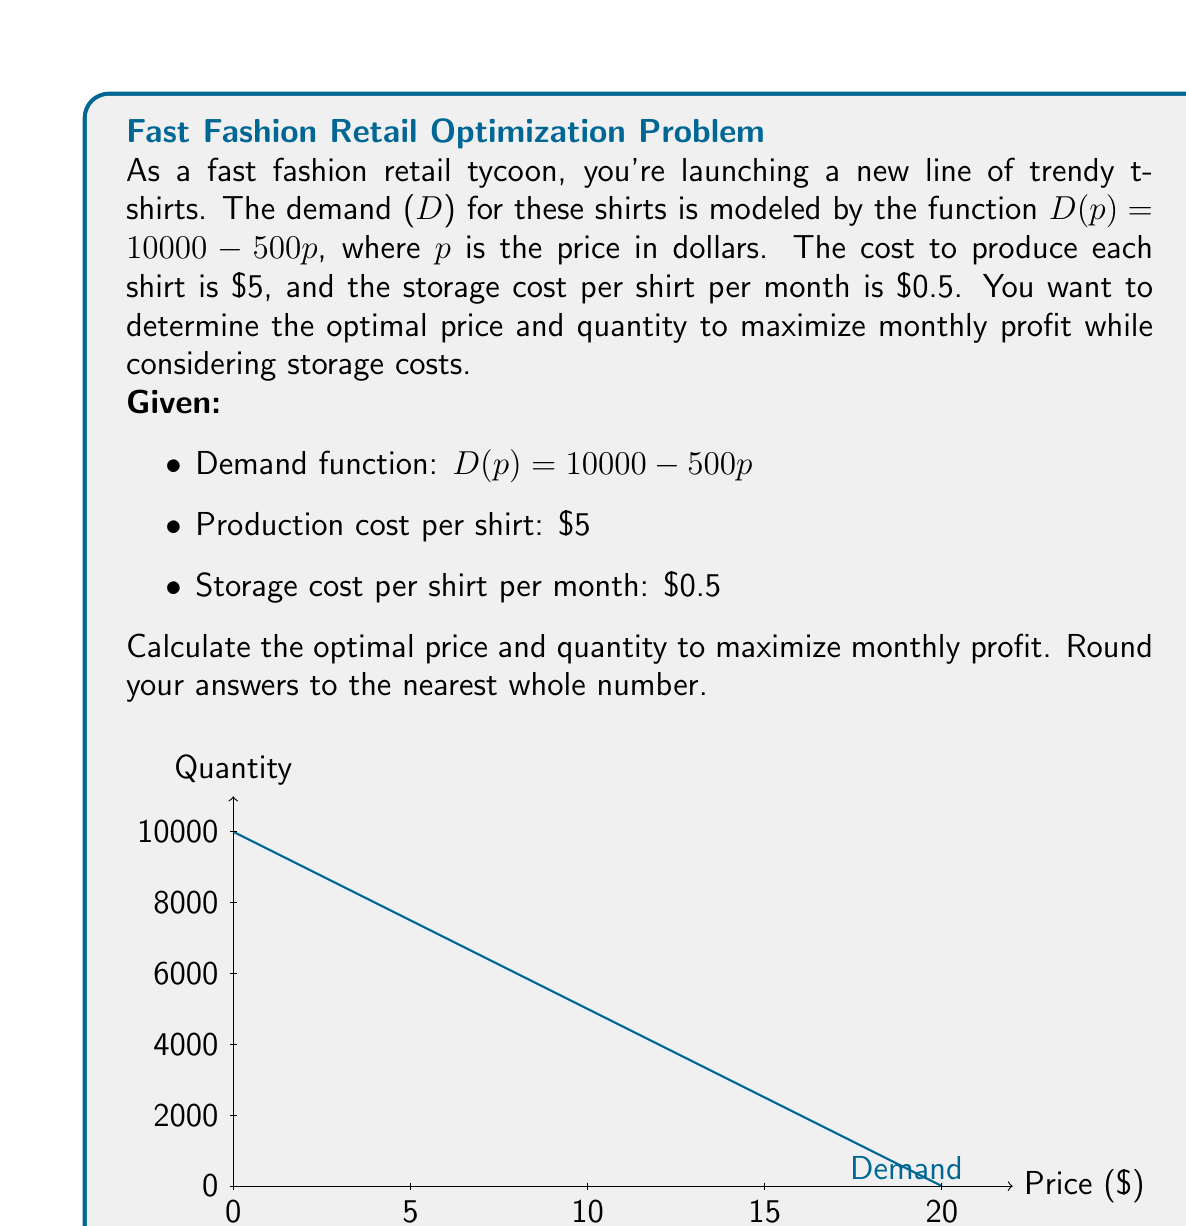Help me with this question. Let's approach this step-by-step:

1) First, we need to express the revenue and cost functions:
   Revenue (R) = p * D(p) = p * (10000 - 500p) = 10000p - 500p²
   Cost (C) = 5D(p) + 0.5D(p) = 5.5D(p) = 5.5(10000 - 500p) = 55000 - 2750p

2) The profit function (P) is revenue minus cost:
   P(p) = R - C = (10000p - 500p²) - (55000 - 2750p)
   P(p) = 10000p - 500p² - 55000 + 2750p
   P(p) = -500p² + 12750p - 55000

3) To maximize profit, we find where the derivative of P(p) equals zero:
   P'(p) = -1000p + 12750 = 0
   1000p = 12750
   p = 12.75

4) The second derivative P''(p) = -1000 < 0, confirming this is a maximum.

5) The optimal price is $12.75. Let's round to $13 for practicality.

6) To find the optimal quantity, we substitute this price into the demand function:
   D(13) = 10000 - 500(13) = 3500

7) Therefore, the optimal quantity is 3500 shirts.

8) Let's verify the profit at these values:
   P(13) = -500(13)² + 12750(13) - 55000 = 27,625

This is indeed the maximum profit when considering both price and storage costs.
Answer: Optimal price: $13, Optimal quantity: 3500 shirts 